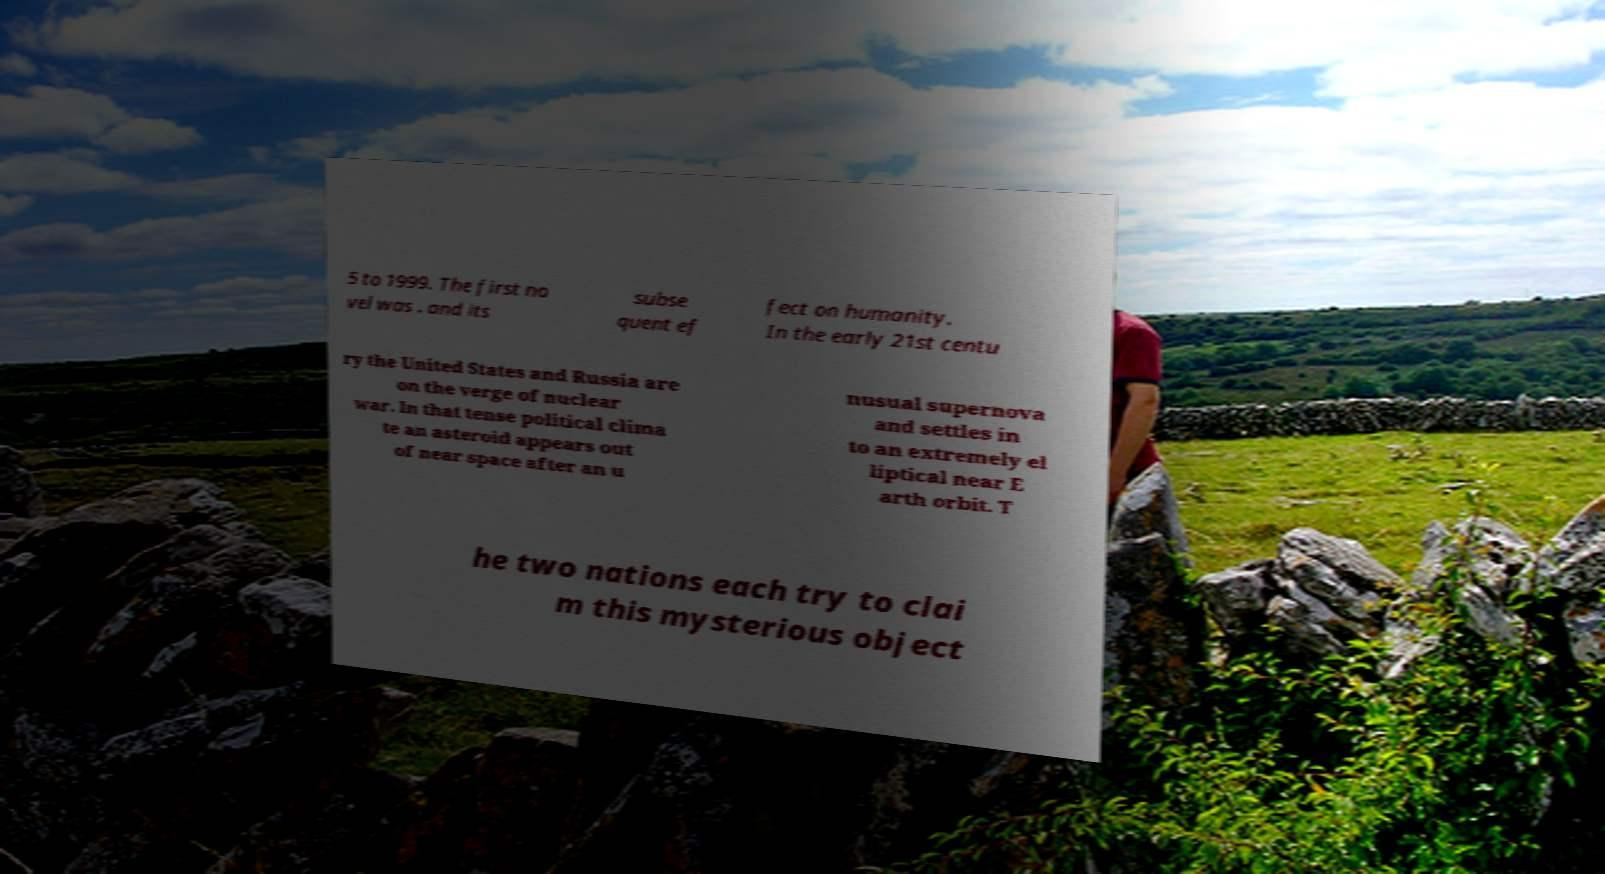What messages or text are displayed in this image? I need them in a readable, typed format. 5 to 1999. The first no vel was . and its subse quent ef fect on humanity. In the early 21st centu ry the United States and Russia are on the verge of nuclear war. In that tense political clima te an asteroid appears out of near space after an u nusual supernova and settles in to an extremely el liptical near E arth orbit. T he two nations each try to clai m this mysterious object 